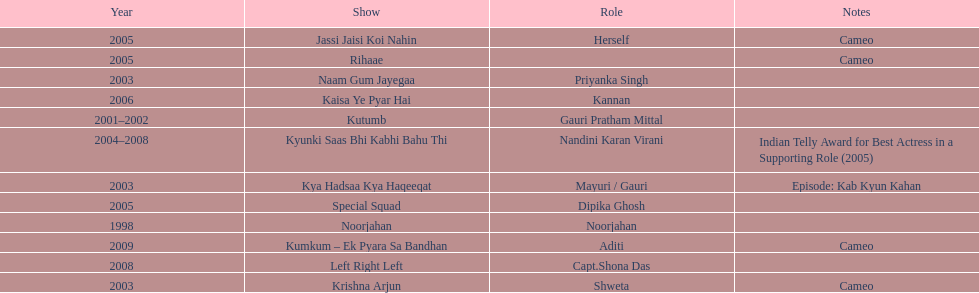How many different tv shows was gauri tejwani in before 2000? 1. 